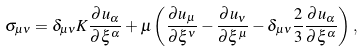Convert formula to latex. <formula><loc_0><loc_0><loc_500><loc_500>\sigma _ { \mu \nu } = \delta _ { \mu \nu } K \frac { \partial u _ { \alpha } } { \partial \xi ^ { \alpha } } + \mu \left ( \frac { \partial u _ { \mu } } { \partial \xi ^ { \nu } } - \frac { \partial u _ { \nu } } { \partial \xi ^ { \mu } } - \delta _ { \mu \nu } \frac { 2 } { 3 } \frac { \partial u _ { \alpha } } { \partial \xi ^ { \alpha } } \right ) ,</formula> 